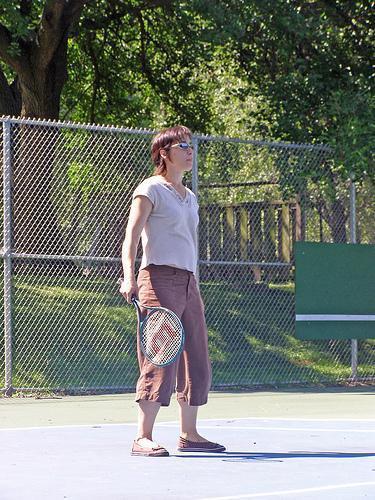How many people are in the picture?
Give a very brief answer. 1. 